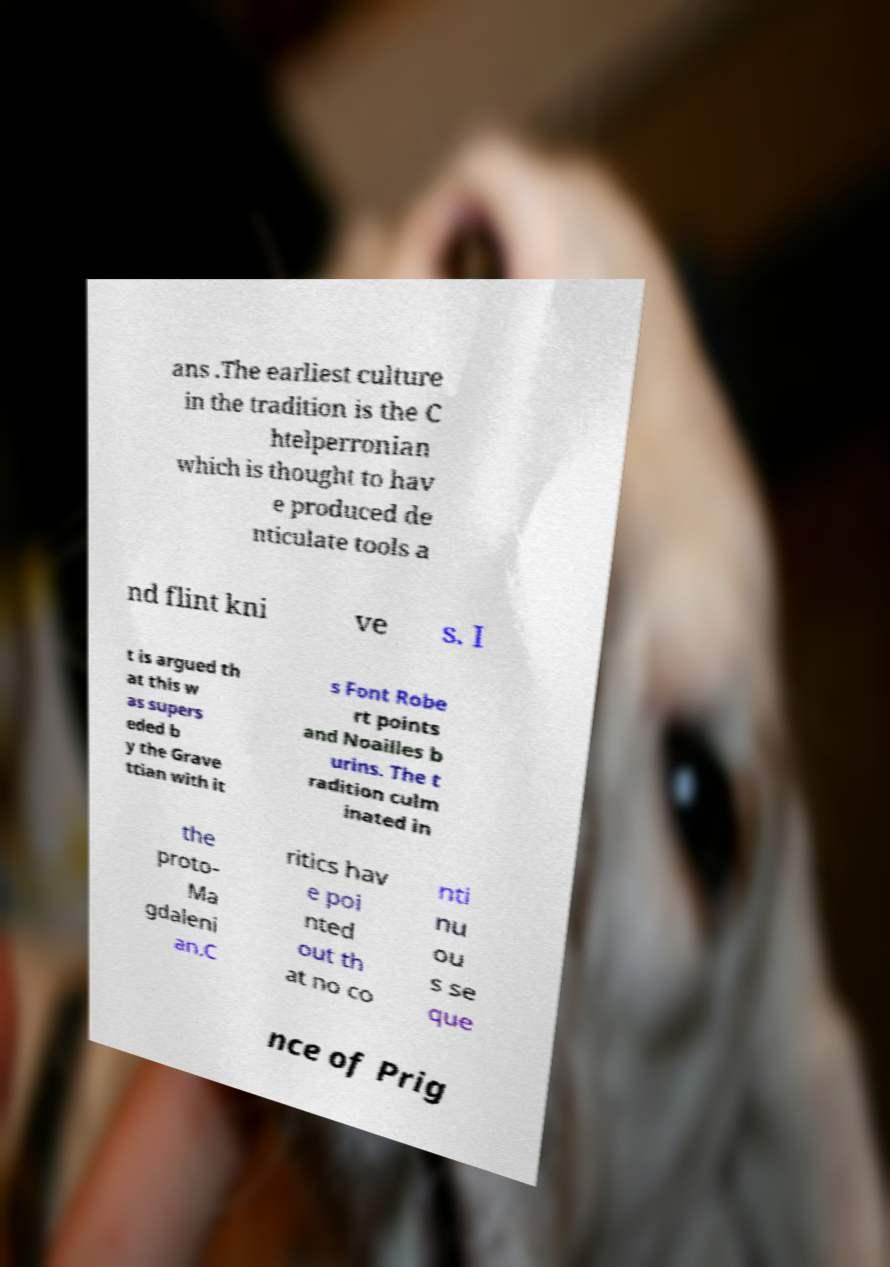Please identify and transcribe the text found in this image. ans .The earliest culture in the tradition is the C htelperronian which is thought to hav e produced de nticulate tools a nd flint kni ve s. I t is argued th at this w as supers eded b y the Grave ttian with it s Font Robe rt points and Noailles b urins. The t radition culm inated in the proto- Ma gdaleni an.C ritics hav e poi nted out th at no co nti nu ou s se que nce of Prig 